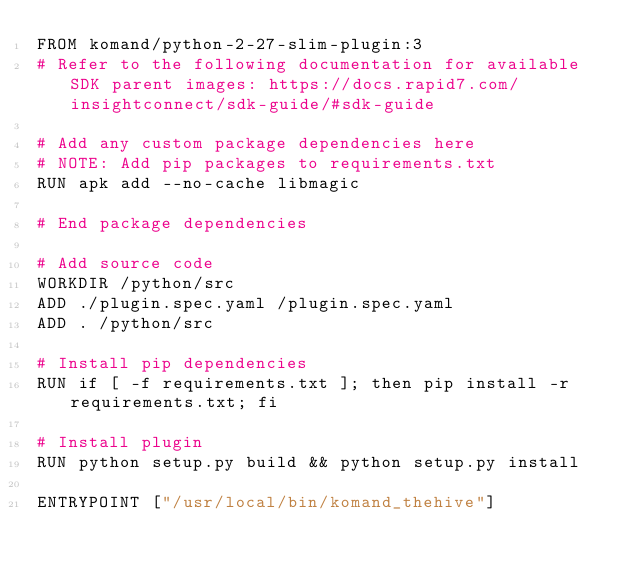<code> <loc_0><loc_0><loc_500><loc_500><_Dockerfile_>FROM komand/python-2-27-slim-plugin:3
# Refer to the following documentation for available SDK parent images: https://docs.rapid7.com/insightconnect/sdk-guide/#sdk-guide

# Add any custom package dependencies here
# NOTE: Add pip packages to requirements.txt
RUN apk add --no-cache libmagic

# End package dependencies

# Add source code
WORKDIR /python/src
ADD ./plugin.spec.yaml /plugin.spec.yaml
ADD . /python/src

# Install pip dependencies
RUN if [ -f requirements.txt ]; then pip install -r requirements.txt; fi

# Install plugin
RUN python setup.py build && python setup.py install

ENTRYPOINT ["/usr/local/bin/komand_thehive"]
</code> 